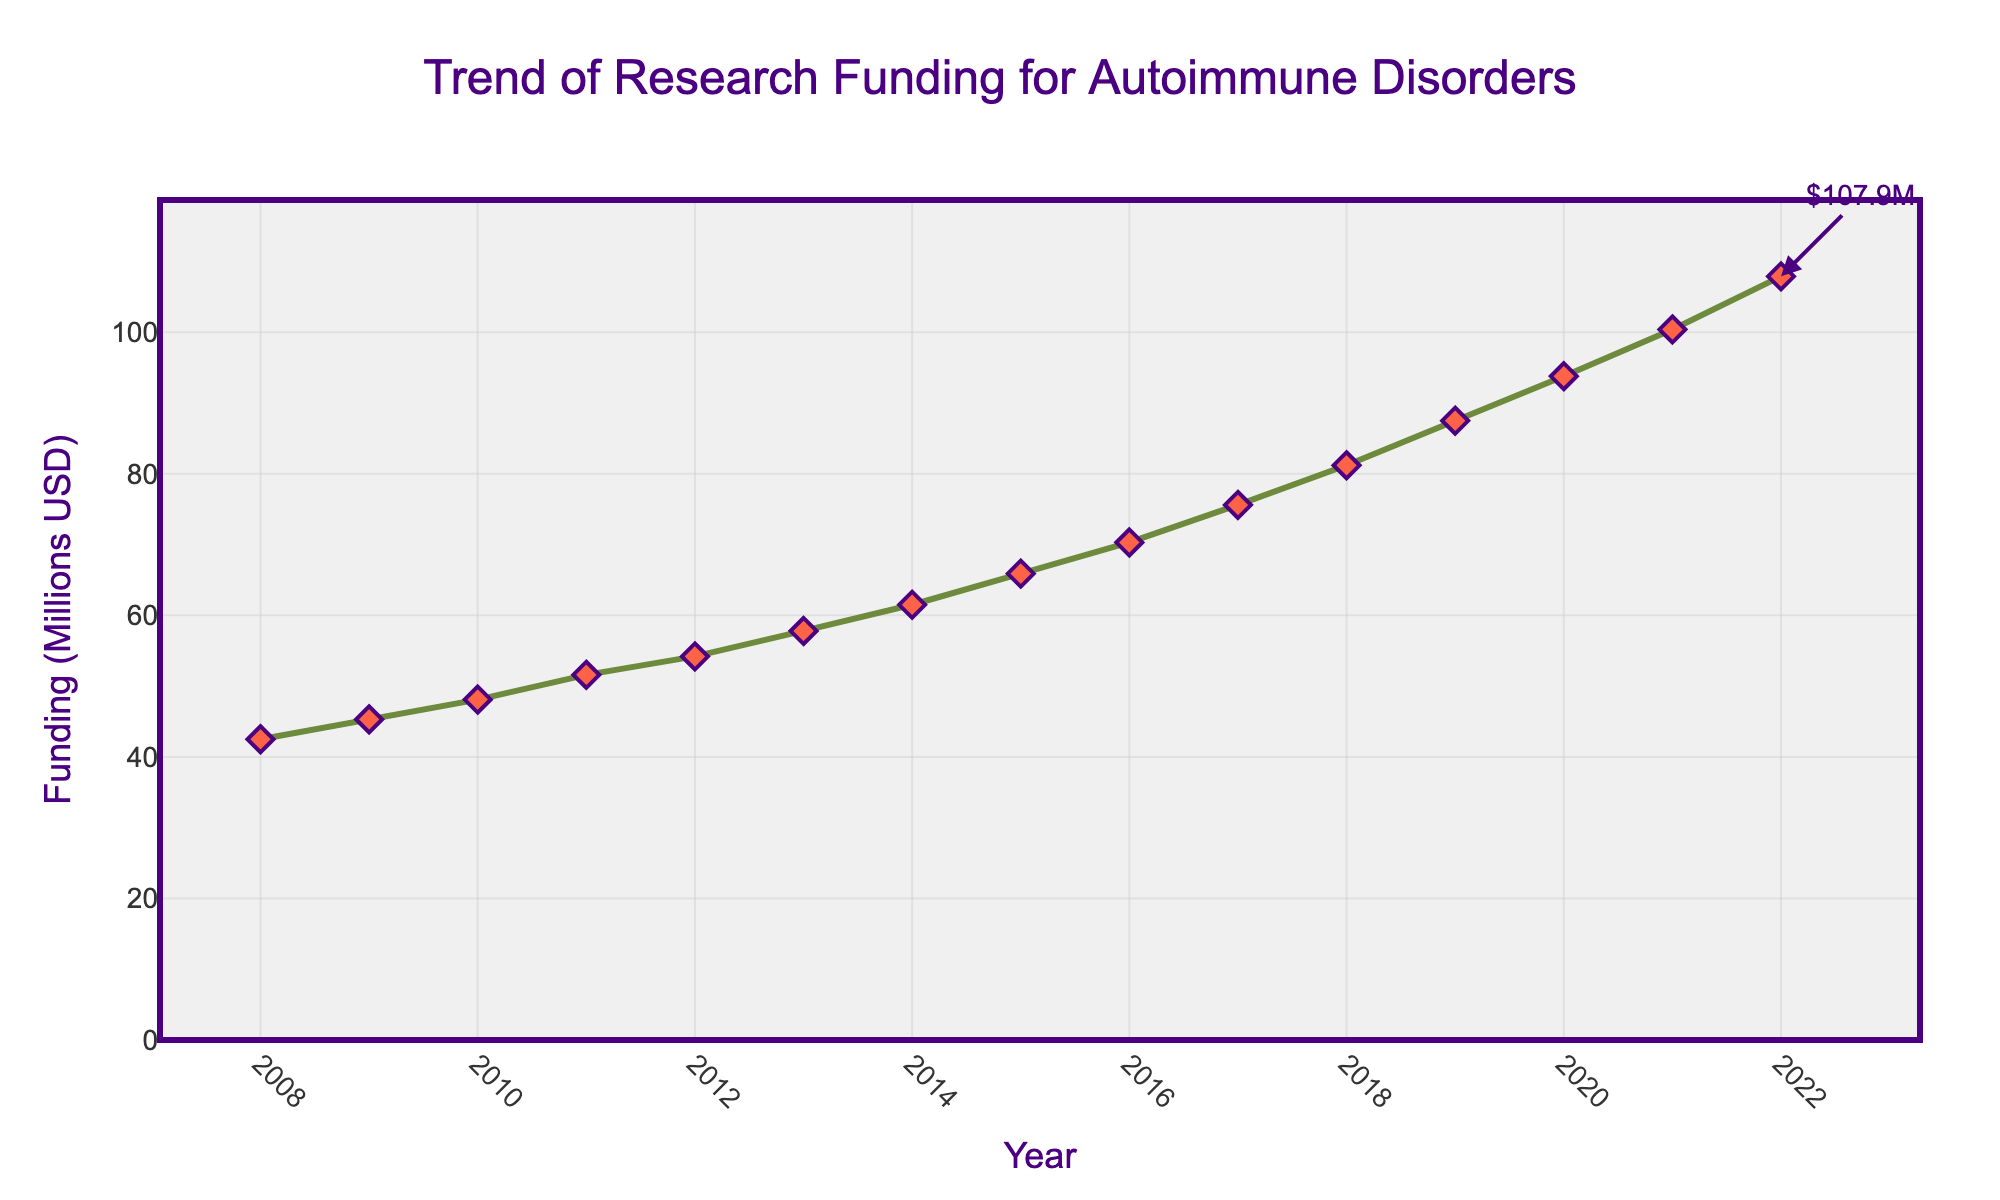What was the lowest amount of research funding in the given years? The lowest value can be identified by looking at the beginning of the line chart and it corresponds to the year 2008.
Answer: 42.5 million USD In which year did the funding first exceed 50 million USD? We need to find the first year where the funding value on the y-axis goes above the 50 million mark. This occurred in 2011.
Answer: 2011 By how much did the research funding increase from 2008 to 2022? The funding in 2008 was 42.5 million USD and in 2022 it was 107.9 million USD. The increase is 107.9 - 42.5 = 65.4 million USD.
Answer: 65.4 million USD What's the average annual research funding over the period shown? Sum the funding values from each year and divide by the number of years, which is 15. The total sum is 1079.6 million USD, so the average is 1079.6 / 15 = 71.973 million USD.
Answer: 71.973 million USD Which year saw the highest increase in research funding compared to the previous year? Calculate the year-on-year difference and find the maximum increase. The largest increase was from 2019 (87.5) to 2020 (93.8), which is 6.3 million USD.
Answer: 2020 What is the percentage increase in research funding from 2008 to 2022? The percentage increase is calculated as ((107.9 - 42.5) / 42.5) x 100%. This results in approximately 153.65%.
Answer: 153.65% How does the trend of research funding from 2008 to 2012 compare with the trend from 2018 to 2022? Calculate the trend by examining the funding increase in both periods. 2008 to 2012 increased from 42.5 to 54.2 million USD, which is 11.7 million USD, while 2018 to 2022 increased from 81.2 to 107.9 million USD, which is 26.7 million USD. Thus, the trend shows a greater increase in the later period.
Answer: Later period shows greater increase Between which consecutive years was the smallest funding increase observed? Calculate and compare the yearly increments. The smallest funding increase was from 2012 (54.2) to 2013 (57.8), which is 3.6 million USD.
Answer: 2012 to 2013 